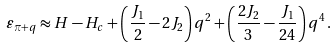<formula> <loc_0><loc_0><loc_500><loc_500>\varepsilon _ { \pi + q } \approx H - H _ { c } + \left ( \frac { J _ { 1 } } { 2 } - 2 J _ { 2 } \right ) q ^ { 2 } + \left ( \frac { 2 J _ { 2 } } { 3 } - \frac { J _ { 1 } } { 2 4 } \right ) q ^ { 4 } \, .</formula> 